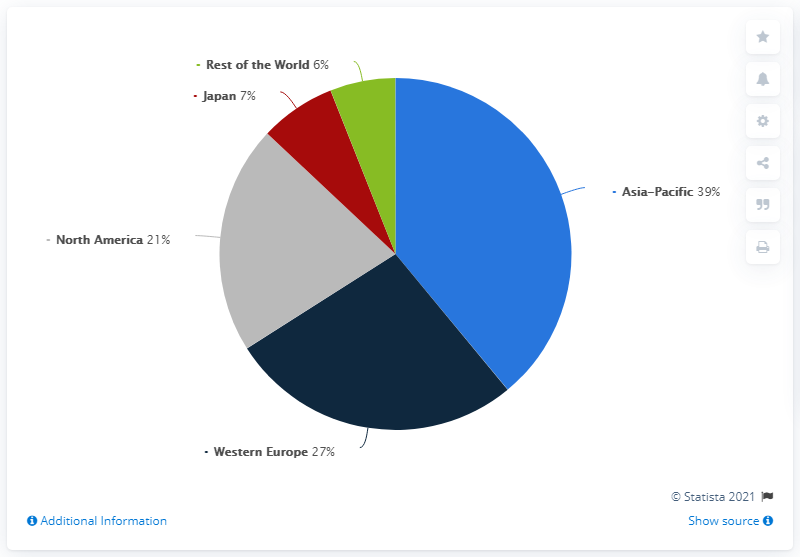Give some essential details in this illustration. The global revenue share of Japan is approximately 7%. The difference between Japan and the rest of the world is only 1%. 